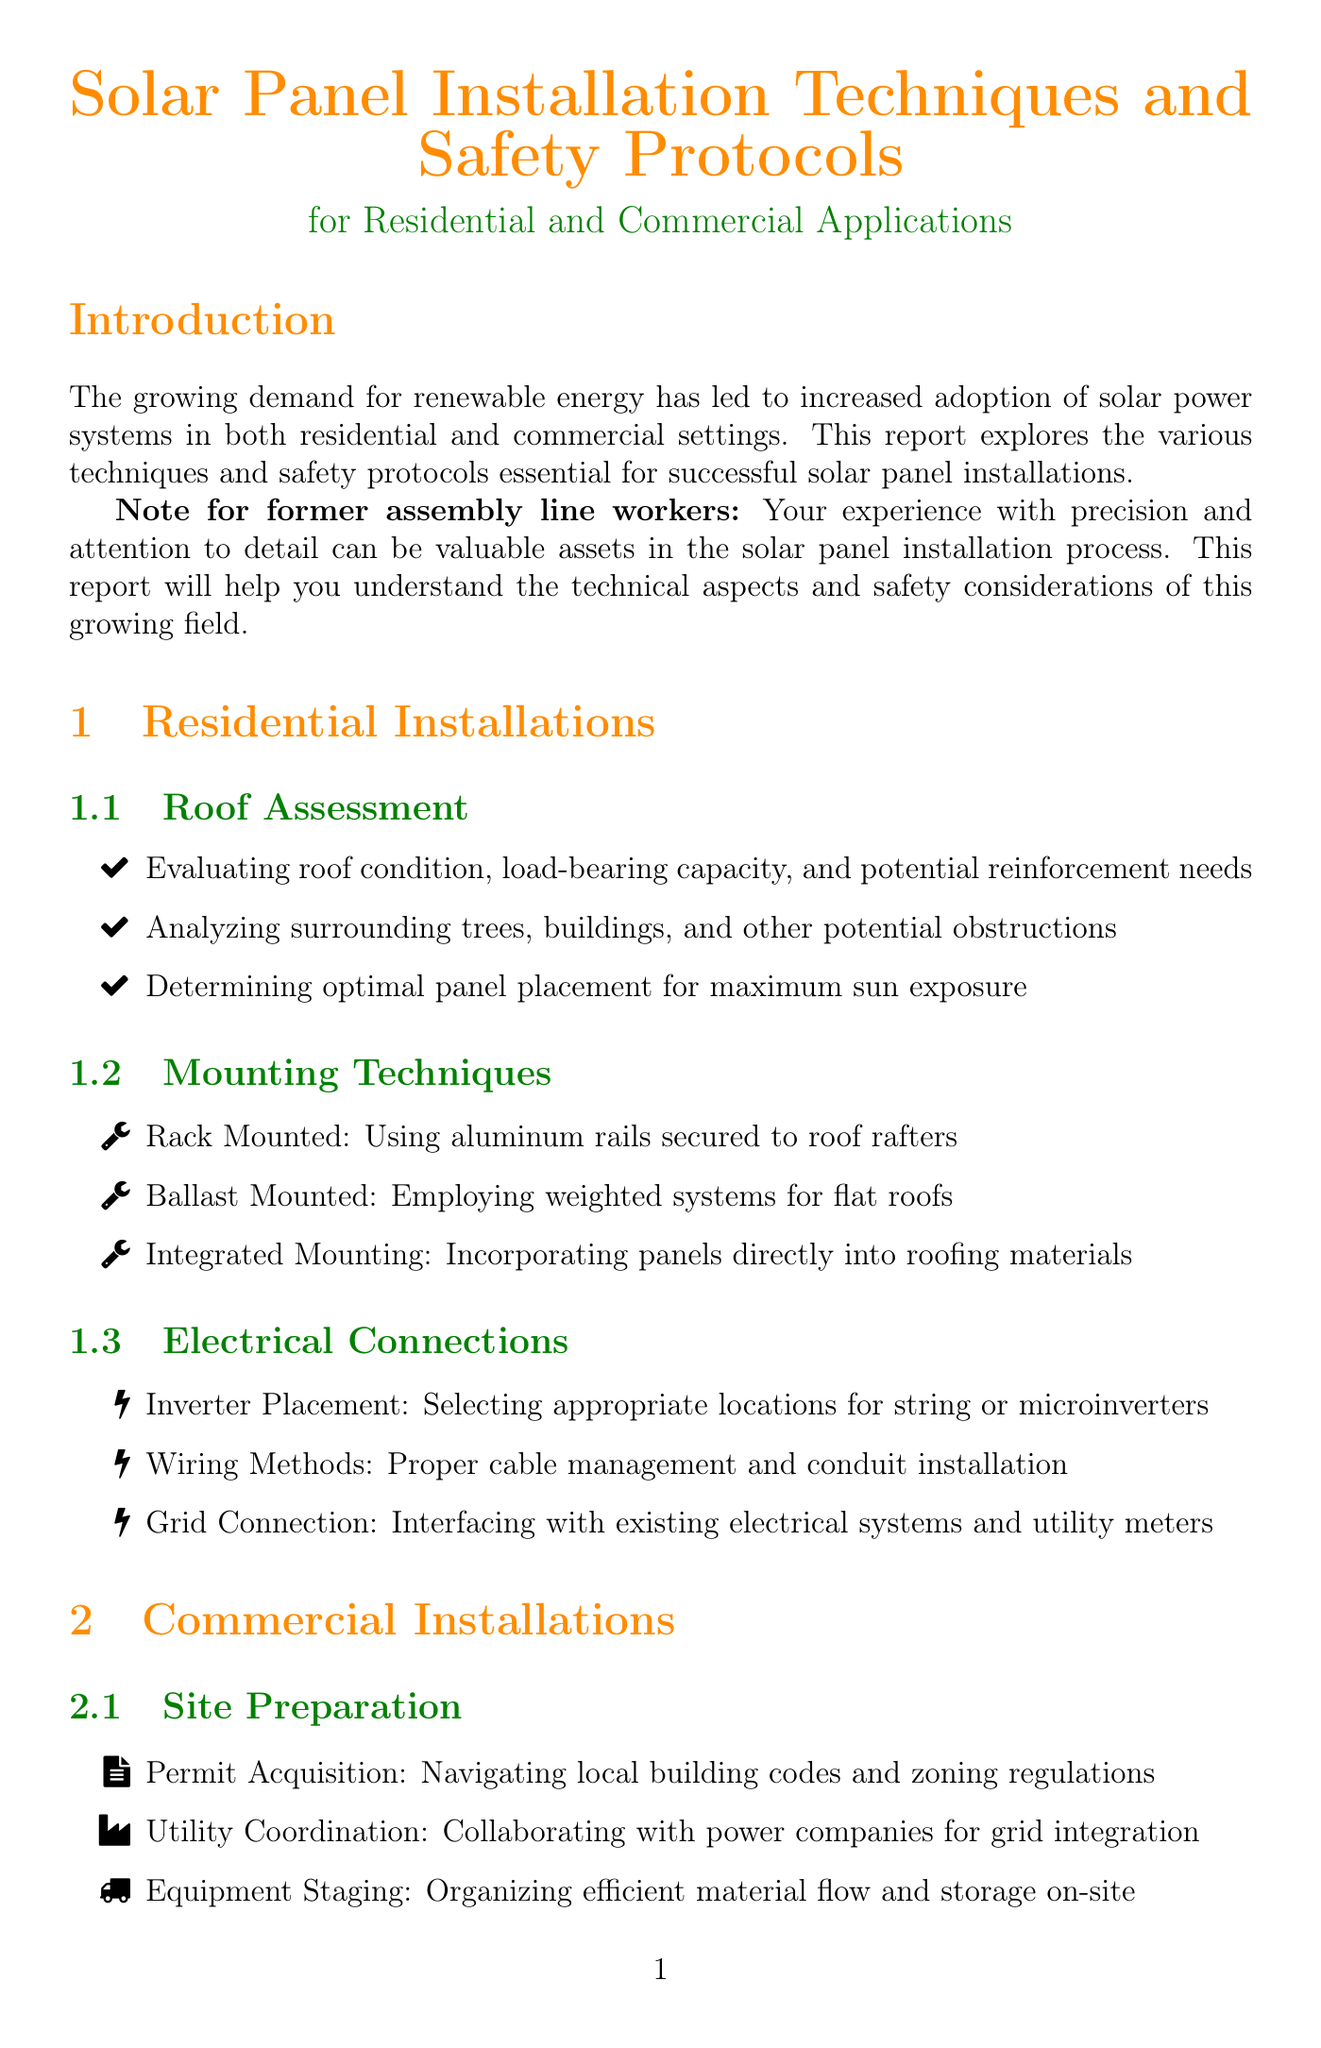What is the report title? The report title is stated at the beginning of the document and indicates the main topic covered.
Answer: Solar Panel Installation Techniques and Safety Protocols for Residential and Commercial Applications What are the three types of residential mounting techniques mentioned? The document outlines specific mounting techniques under the residential installations section.
Answer: Rack Mounted, Ballast Mounted, Integrated Mounting What type of PPE is recommended for eye protection? The safety protocols section specifies the personal protective equipment necessary for the installation process.
Answer: Safety glasses What is one method listed for commercial site preparation? The commercial installations section outlines necessary preparations before installation, including obtaining permits.
Answer: Permit Acquisition What protocol is implemented for electrical safety? The safety protocols section addresses proper procedures to ensure safe handling of electrical systems during installation.
Answer: Lockout/Tagout How many certifications are listed in the industry standards section? The document includes specific certifications within the industry standards section that professionals should obtain.
Answer: Three What is the focus of the conclusion in this report? The conclusion summarizes opportunities and emphasizes the need for ongoing training relevant to the employment of former assembly line workers.
Answer: Career Opportunities What should be checked during the inspection procedures? Under quality assurance, the inspection procedures recommend checks to ensure proper installation.
Answer: Visual Checks What is one aspect of weather considerations mentioned? The document discusses various factors that can impact installation, particularly in relation to weather safety.
Answer: Wind Protocols 